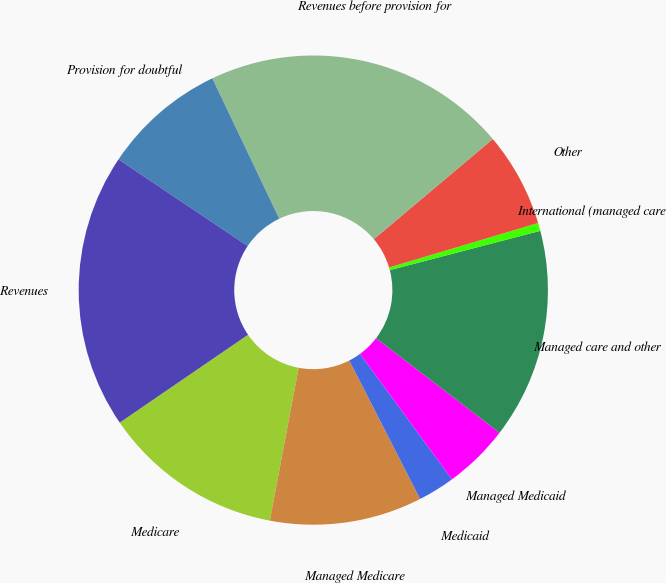Convert chart. <chart><loc_0><loc_0><loc_500><loc_500><pie_chart><fcel>Medicare<fcel>Managed Medicare<fcel>Medicaid<fcel>Managed Medicaid<fcel>Managed care and other<fcel>International (managed care<fcel>Other<fcel>Revenues before provision for<fcel>Provision for doubtful<fcel>Revenues<nl><fcel>12.48%<fcel>10.49%<fcel>2.54%<fcel>4.53%<fcel>14.47%<fcel>0.55%<fcel>6.52%<fcel>20.95%<fcel>8.51%<fcel>18.96%<nl></chart> 